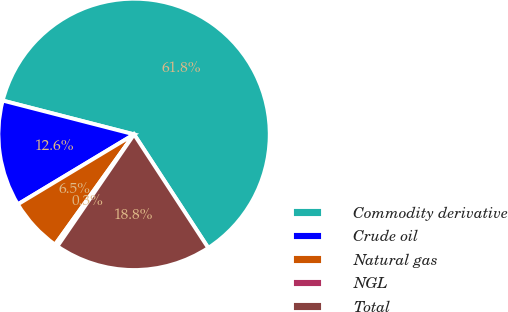Convert chart. <chart><loc_0><loc_0><loc_500><loc_500><pie_chart><fcel>Commodity derivative<fcel>Crude oil<fcel>Natural gas<fcel>NGL<fcel>Total<nl><fcel>61.78%<fcel>12.63%<fcel>6.48%<fcel>0.34%<fcel>18.77%<nl></chart> 